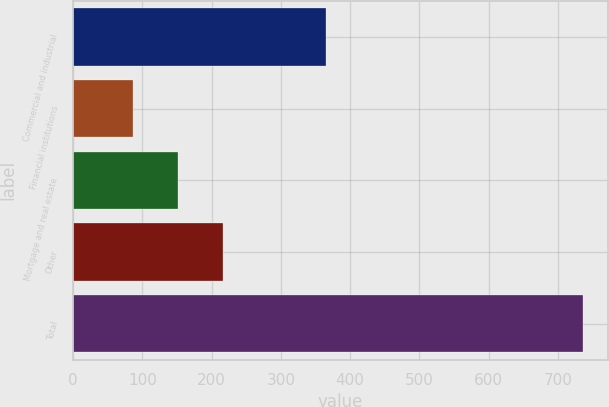<chart> <loc_0><loc_0><loc_500><loc_500><bar_chart><fcel>Commercial and industrial<fcel>Financial institutions<fcel>Mortgage and real estate<fcel>Other<fcel>Total<nl><fcel>365<fcel>87<fcel>151.9<fcel>216.8<fcel>736<nl></chart> 